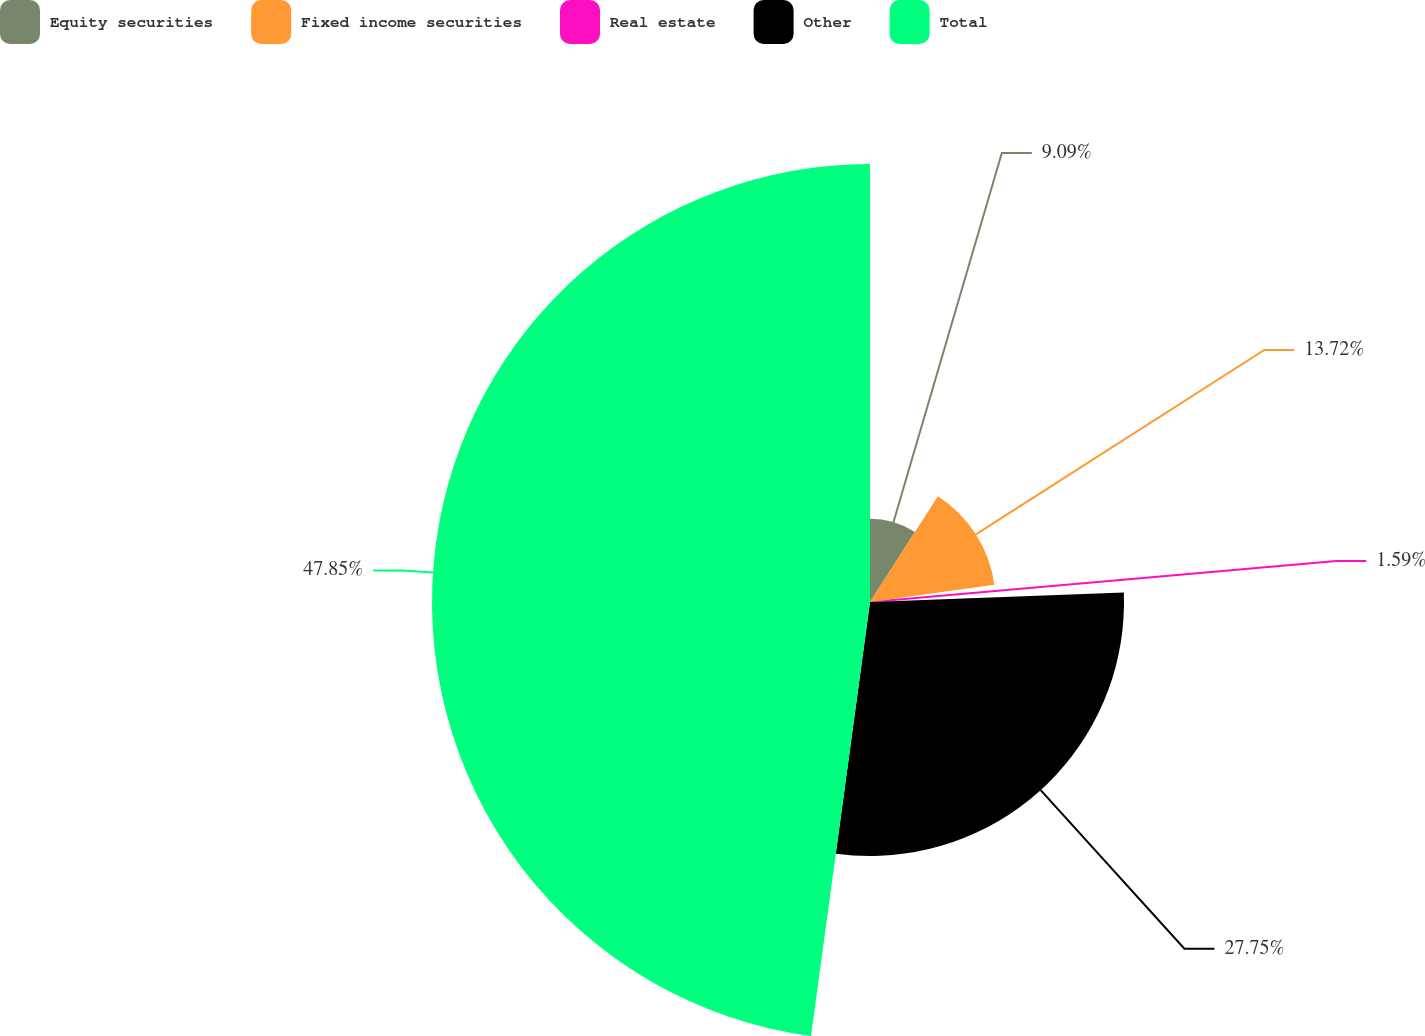Convert chart. <chart><loc_0><loc_0><loc_500><loc_500><pie_chart><fcel>Equity securities<fcel>Fixed income securities<fcel>Real estate<fcel>Other<fcel>Total<nl><fcel>9.09%<fcel>13.72%<fcel>1.59%<fcel>27.75%<fcel>47.85%<nl></chart> 